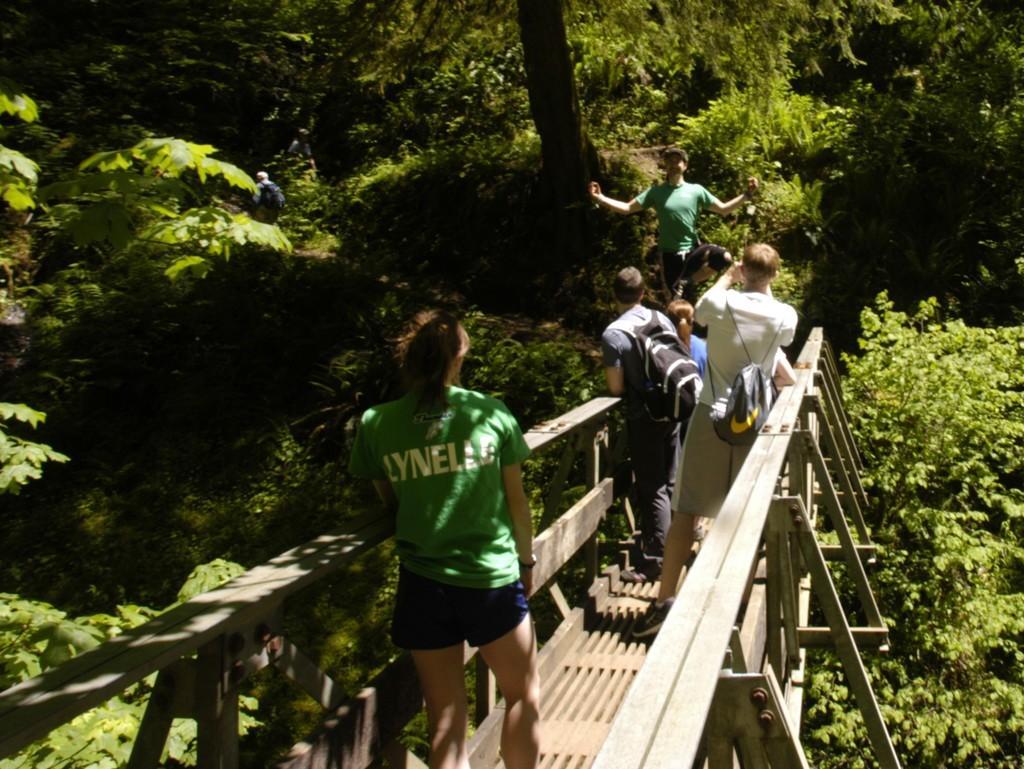In one or two sentences, can you explain what this image depicts? In this image we can see a bridge. There are people. Few are wearing bags. Also there are trees. 